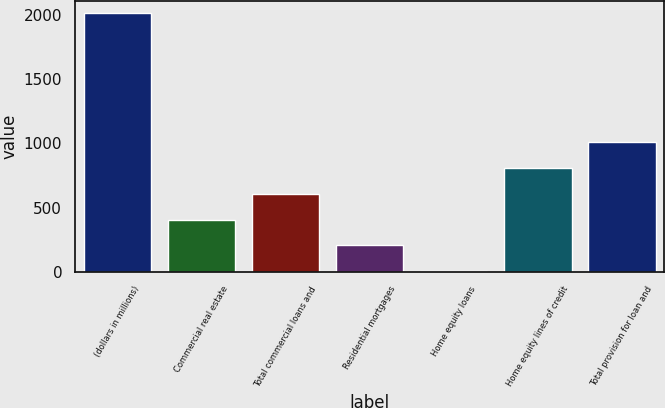Convert chart to OTSL. <chart><loc_0><loc_0><loc_500><loc_500><bar_chart><fcel>(dollars in millions)<fcel>Commercial real estate<fcel>Total commercial loans and<fcel>Residential mortgages<fcel>Home equity loans<fcel>Home equity lines of credit<fcel>Total provision for loan and<nl><fcel>2014<fcel>406<fcel>607<fcel>205<fcel>4<fcel>808<fcel>1009<nl></chart> 